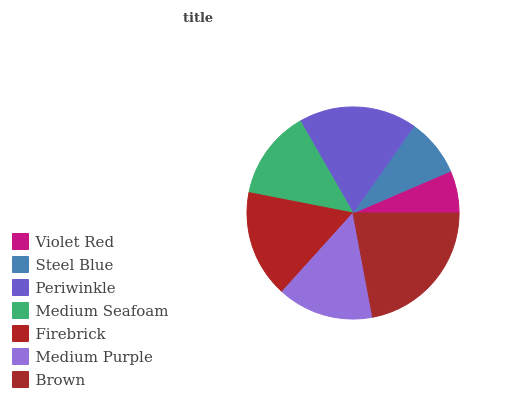Is Violet Red the minimum?
Answer yes or no. Yes. Is Brown the maximum?
Answer yes or no. Yes. Is Steel Blue the minimum?
Answer yes or no. No. Is Steel Blue the maximum?
Answer yes or no. No. Is Steel Blue greater than Violet Red?
Answer yes or no. Yes. Is Violet Red less than Steel Blue?
Answer yes or no. Yes. Is Violet Red greater than Steel Blue?
Answer yes or no. No. Is Steel Blue less than Violet Red?
Answer yes or no. No. Is Medium Purple the high median?
Answer yes or no. Yes. Is Medium Purple the low median?
Answer yes or no. Yes. Is Violet Red the high median?
Answer yes or no. No. Is Violet Red the low median?
Answer yes or no. No. 